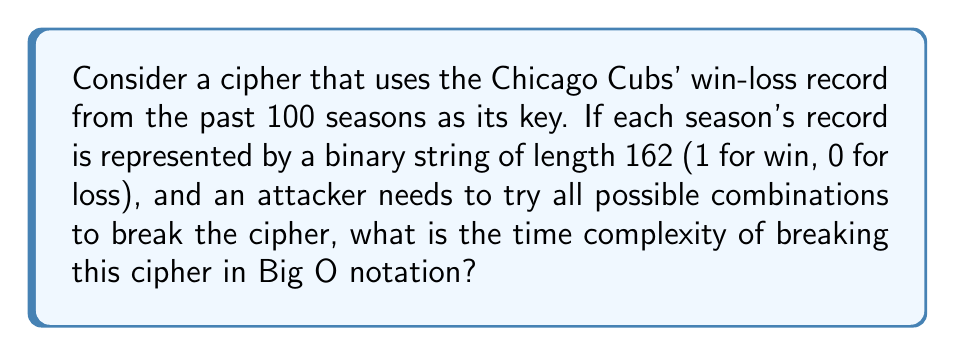Show me your answer to this math problem. Let's approach this step-by-step:

1) Each season has 162 games, so each season's record is a binary string of length 162.

2) There are 100 seasons in total, so the entire key is a binary string of length:
   $$ 162 \times 100 = 16,200 $$

3) For a binary string of length $n$, there are $2^n$ possible combinations.

4) In this case, the number of possible combinations is:
   $$ 2^{16,200} $$

5) To break the cipher, an attacker would need to try all these combinations in the worst case.

6) The time complexity of trying all combinations is proportional to the number of combinations.

7) In Big O notation, we express this as:
   $$ O(2^{16,200}) $$

This is an exponential time complexity, which is typical for brute-force attacks on cryptographic systems.
Answer: $O(2^{16,200})$ 